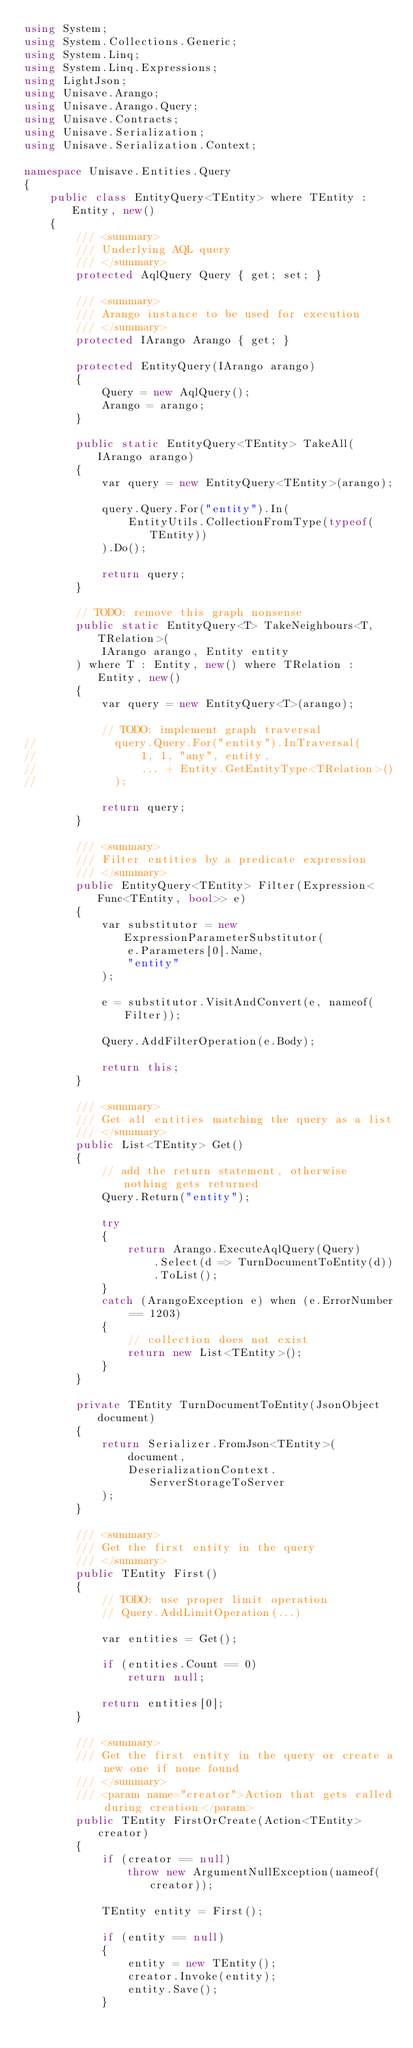<code> <loc_0><loc_0><loc_500><loc_500><_C#_>using System;
using System.Collections.Generic;
using System.Linq;
using System.Linq.Expressions;
using LightJson;
using Unisave.Arango;
using Unisave.Arango.Query;
using Unisave.Contracts;
using Unisave.Serialization;
using Unisave.Serialization.Context;

namespace Unisave.Entities.Query
{
    public class EntityQuery<TEntity> where TEntity : Entity, new()
    {
        /// <summary>
        /// Underlying AQL query
        /// </summary>
        protected AqlQuery Query { get; set; }
        
        /// <summary>
        /// Arango instance to be used for execution
        /// </summary>
        protected IArango Arango { get; }
        
        protected EntityQuery(IArango arango)
        {
            Query = new AqlQuery();
            Arango = arango;
        }

        public static EntityQuery<TEntity> TakeAll(IArango arango)
        {
            var query = new EntityQuery<TEntity>(arango);
            
            query.Query.For("entity").In(
                EntityUtils.CollectionFromType(typeof(TEntity))
            ).Do();
            
            return query;
        }
        
        // TODO: remove this graph nonsense
        public static EntityQuery<T> TakeNeighbours<T, TRelation>(
            IArango arango, Entity entity
        ) where T : Entity, new() where TRelation : Entity, new()
        {
            var query = new EntityQuery<T>(arango);
            
            // TODO: implement graph traversal
//            query.Query.For("entity").InTraversal(
//                1, 1, "any", entity,
//                ... + Entity.GetEntityType<TRelation>()
//            );
            
            return query;
        }

        /// <summary>
        /// Filter entities by a predicate expression
        /// </summary>
        public EntityQuery<TEntity> Filter(Expression<Func<TEntity, bool>> e)
        {
            var substitutor = new ExpressionParameterSubstitutor(
                e.Parameters[0].Name,
                "entity"
            );

            e = substitutor.VisitAndConvert(e, nameof(Filter));
            
            Query.AddFilterOperation(e.Body);
            
            return this;
        }

        /// <summary>
        /// Get all entities matching the query as a list
        /// </summary>
        public List<TEntity> Get()
        {
            // add the return statement, otherwise nothing gets returned
            Query.Return("entity");

            try
            {
                return Arango.ExecuteAqlQuery(Query)
                    .Select(d => TurnDocumentToEntity(d))
                    .ToList();
            }
            catch (ArangoException e) when (e.ErrorNumber == 1203)
            {
                // collection does not exist
                return new List<TEntity>();
            }
        }

        private TEntity TurnDocumentToEntity(JsonObject document)
        {
            return Serializer.FromJson<TEntity>(
                document,
                DeserializationContext.ServerStorageToServer
            );
        }

        /// <summary>
        /// Get the first entity in the query
        /// </summary>
        public TEntity First()
        {
            // TODO: use proper limit operation
            // Query.AddLimitOperation(...)

            var entities = Get();
            
            if (entities.Count == 0)
                return null;

            return entities[0];
        }

        /// <summary>
        /// Get the first entity in the query or create a new one if none found
        /// </summary>
        /// <param name="creator">Action that gets called during creation</param>
        public TEntity FirstOrCreate(Action<TEntity> creator)
        {
            if (creator == null)
                throw new ArgumentNullException(nameof(creator));

            TEntity entity = First();

            if (entity == null)
            {
                entity = new TEntity();
                creator.Invoke(entity);
                entity.Save();
            }
</code> 